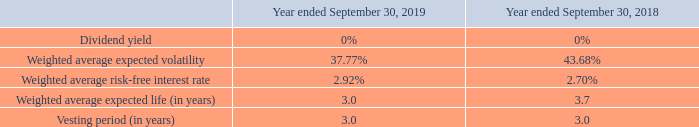The Company currently has one equity compensation plan, the 2007 Stock Compensation Plan, from which it grants equity awards that are used as an incentive for directors, officers, and other employees. The 2007 Stock Compensation Plan has 851,134 shares available for issue as of September 30, 2019. As of September 30, 2019, $2,371,309 of total unrecognized compensation expense related to non-vested awards is expected to be recognized over a period of approximately 4.9 years. The Company recorded related compensation expense for the years ended September 30, 2019, 2018, and 2017 of $1,729,025, $2,003,207, and $2,319,975, respectively. For the year ended September 30, 2019, $1,638,829 of this expense was included in selling, general and administrative expense and $90,196 was included in cost of sales. For the year ended September 30, 2018, $1,835,086 of this expense was included in selling, general and administrative expense and $168,121 was included in cost of sales. For the year ended September 30, 2017, $2,103,621 of this expense was included in selling, general and administrative expense and $216,354 was included in cost of sales.
Stock Options: The Company uses the Black-Scholes option pricing model to determine the weighted average fair value of options granted. During the fiscal year ended September 30, 2019, the Company granted employees non-qualified stock options to purchase an aggregate of 172,000 shares of common stock with a weighted average contractual term of 4 years, a three year vesting term, and a weighted average exercise price of $12.17. During the fiscal year ended September 30, 2018, the Company granted employees non-qualified stock options to purchase an aggregate of 108,000 shares of common stock with a weighted average contractual term of 4.7 years, a three year vesting term, and a weighted average exercise price of $13.37. There were no stock options granted during the year ended September 30, 2017. The fair value was estimated at the grant date using the assumptions listed below:
The expected stock price volatility is based on the historical volatility of the Company’s stock for a period approximating the expected life. The expected life represents the period of time that options are expected to be outstanding after their grant date. The risk-free interest rate reflects the interest rate at grant date on zero-coupon U.S. governmental bonds having a remaining life similar to the expected option term.
Options are generally granted at fair market values determined on the date of grant and vesting normally occurs over a three to five-year period. However, options granted to directors have a one year vesting period and a six year contractual term. The maximum contractual term is normally six years. Shares issued upon exercise of a stock option are issued from the Company’s authorized but unissued shares. There were 36,000 options vested during the year ended September 30, 2019 and no options vested during the year ended September 30 2018. For the year ended September 30, 2019, there were 6,750 stock options that were exercised using a cashless method of exercise. For the year ended September 30, 2018, there were 2,250 stock options that were exercised using a cashless method of exercise. The intrinsic value of options exercised during the years ended September 30, 2019 and September 30, 2018 was $81,728 and $75,767, respectively.
What is the model used to determine the weighted average fair value of options granted? Black-scholes option pricing model. What is the weighted average exercise price during the fiscal year ended September 30, 2019? $12.17. What is the vesting period (in years) in for the year ended September 30,2019? 3.0. What is the average vesting period for 2018 and 2019? (3.0+3.0)/2
Answer: 3. What is the percentage change in the compensation expense from 2018 to 2019?
Answer scale should be: percent. (1,729,025-2,003,207)/2,003,207
Answer: -13.69. What is the change in the percentage of weighted average expected volatility from 2018 to 2019?
Answer scale should be: percent. 37.77-43.68
Answer: -5.91. 